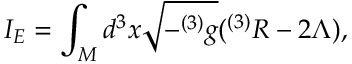<formula> <loc_0><loc_0><loc_500><loc_500>I _ { E } = \int _ { M } d ^ { 3 } x \sqrt { - ^ { ( 3 ) } g } ( ^ { ( 3 ) } R - 2 \Lambda ) ,</formula> 